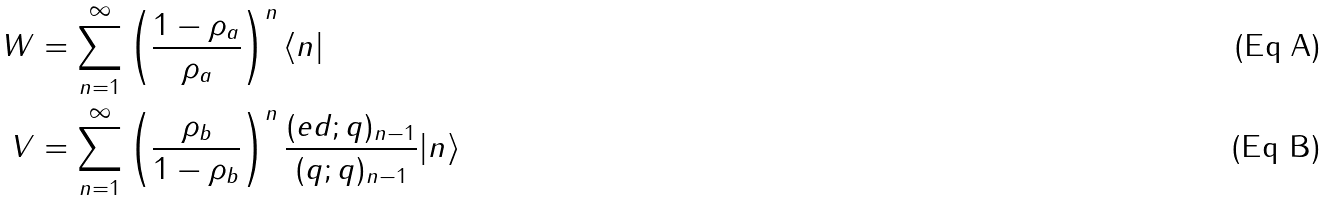<formula> <loc_0><loc_0><loc_500><loc_500>\ W & = \sum _ { n = 1 } ^ { \infty } \left ( \frac { 1 - \rho _ { a } } { \rho _ { a } } \right ) ^ { n } \langle n | \\ \ V & = \sum _ { n = 1 } ^ { \infty } \left ( \frac { \rho _ { b } } { 1 - \rho _ { b } } \right ) ^ { n } \frac { ( e d ; q ) _ { n - 1 } } { ( q ; q ) _ { n - 1 } } | n \rangle</formula> 